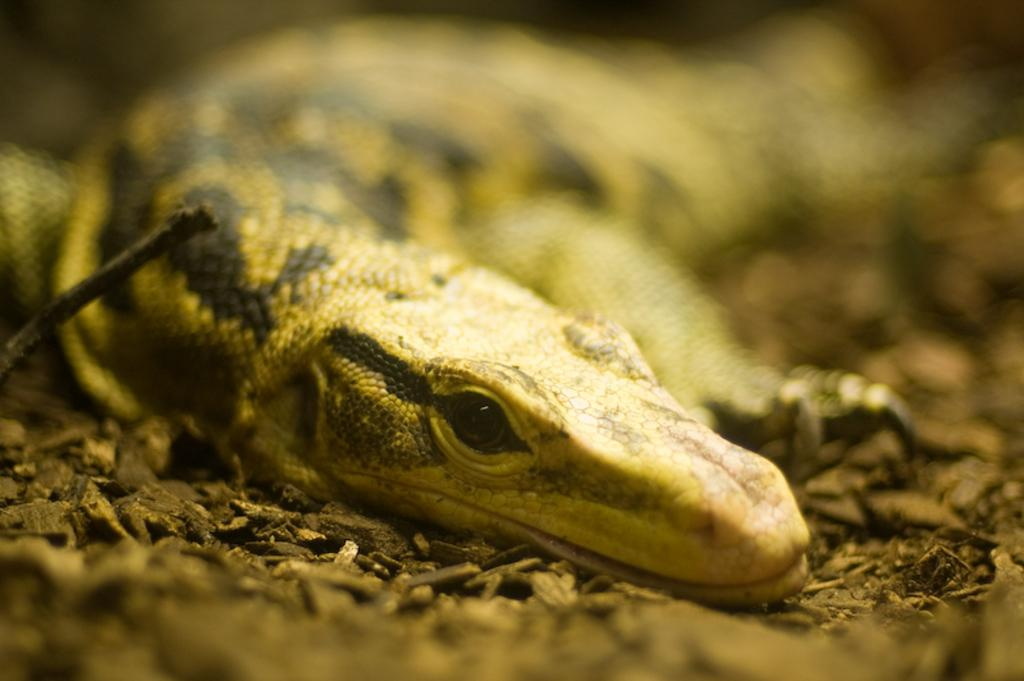What type of animal is in the image? There is a lizard in the image. Can you describe the background of the image? The background of the image is blurred. What type of bird is shown sorting items in the image? There is no bird sorting items in the image; it features a lizard and a blurred background. 